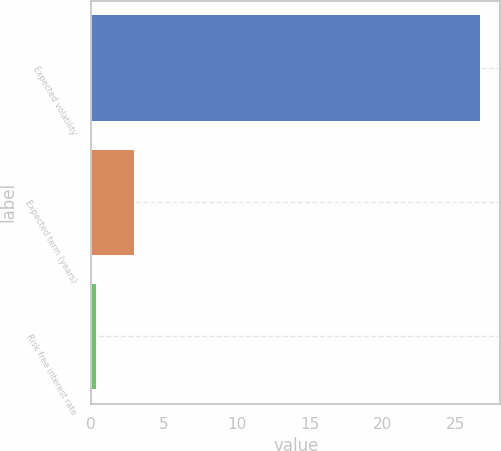Convert chart. <chart><loc_0><loc_0><loc_500><loc_500><bar_chart><fcel>Expected volatility<fcel>Expected term (years)<fcel>Risk free interest rate<nl><fcel>26.76<fcel>3.03<fcel>0.39<nl></chart> 